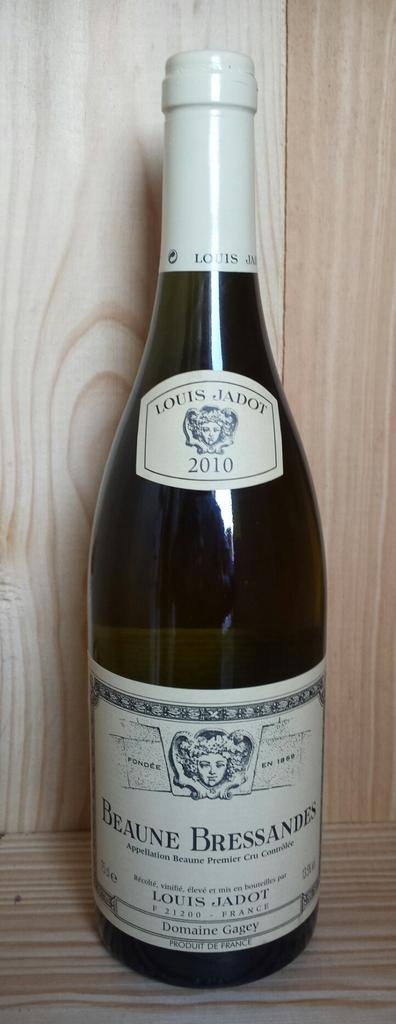<image>
Offer a succinct explanation of the picture presented. A bottle of wine with the words Beaune Bressandes on the label. 